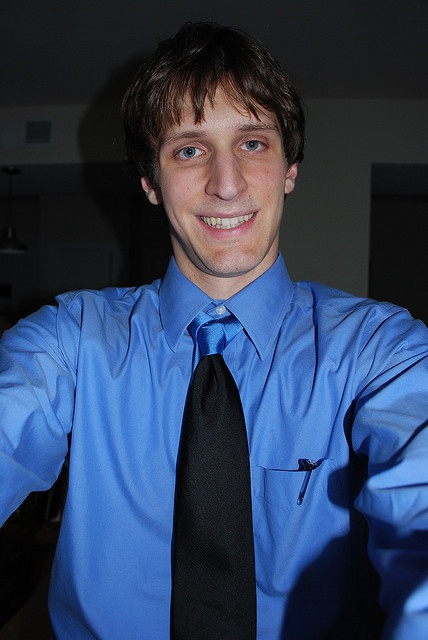Describe the objects in this image and their specific colors. I can see people in black, gray, and blue tones and tie in black, navy, gray, and blue tones in this image. 